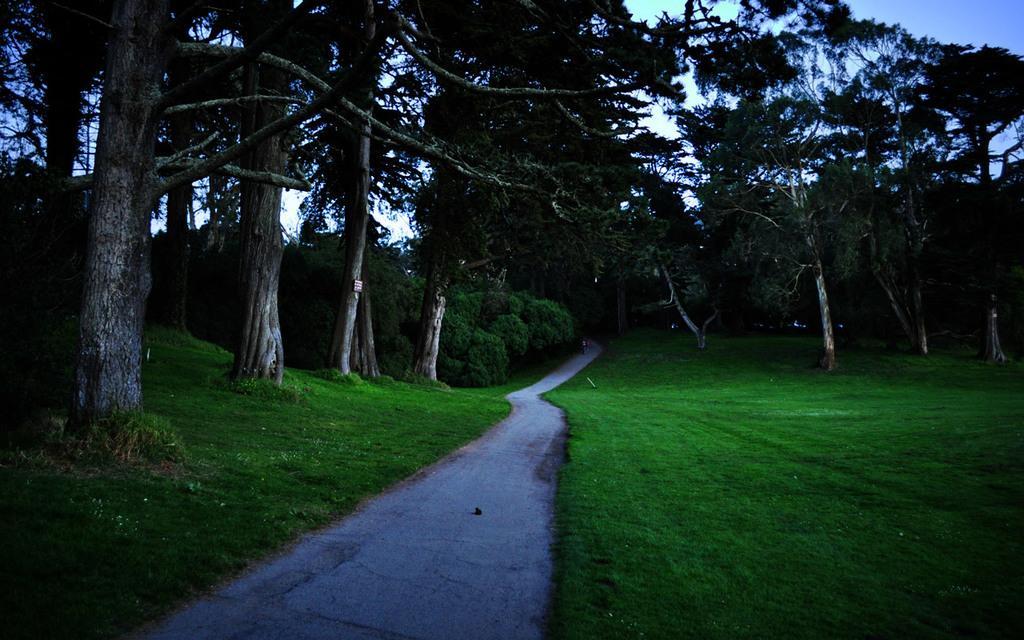How would you summarize this image in a sentence or two? In this picture we can see some tree and grass beside the road. 